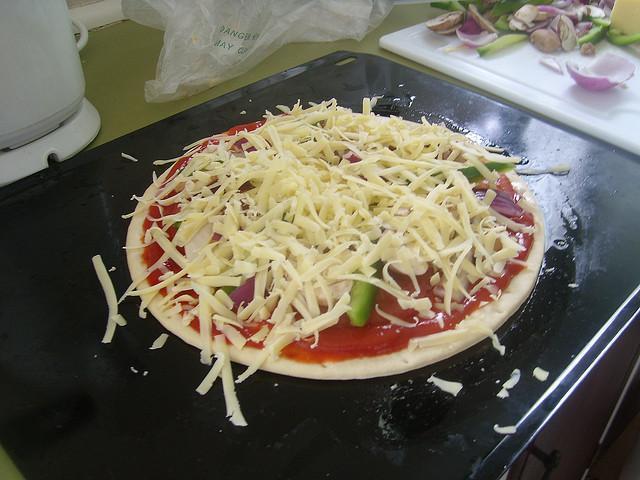How many pizzas are visible?
Give a very brief answer. 1. 